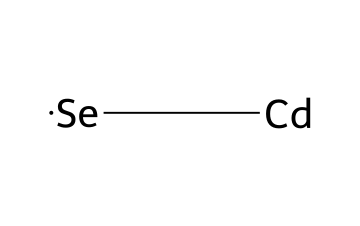What elements make up this chemical? The SMILES representation shows two elements: cadmium (Cd) and selenium (Se). Each element can be identified based on its symbol.
Answer: cadmium and selenium How many atoms are present in this molecule? The structure indicates one cadmium atom and one selenium atom, totaling two atoms in the molecule.
Answer: two What is the primary use of these quantum dots? Quantum dots are commonly used in displays and medical imaging due to their unique optical properties.
Answer: displays and medical imaging What type of bonding is present in this compound? The cadmium and selenium atoms are bonded together through ionic or covalent interactions, indicating a bond between a metal and a non-metal.
Answer: ionic or covalent What color do quantum dot-infused paints typically emit? The color emitted by quantum dots can vary based on their size, but they often emit bright colors such as green, red, or blue.
Answer: colors like green, red, or blue How does the size of quantum dots affect their color? The size of quantum dots influences their band gap, which in turn affects their emission wavelength; smaller dots emit blue light while larger dots emit red light.
Answer: size influences emission wavelength 